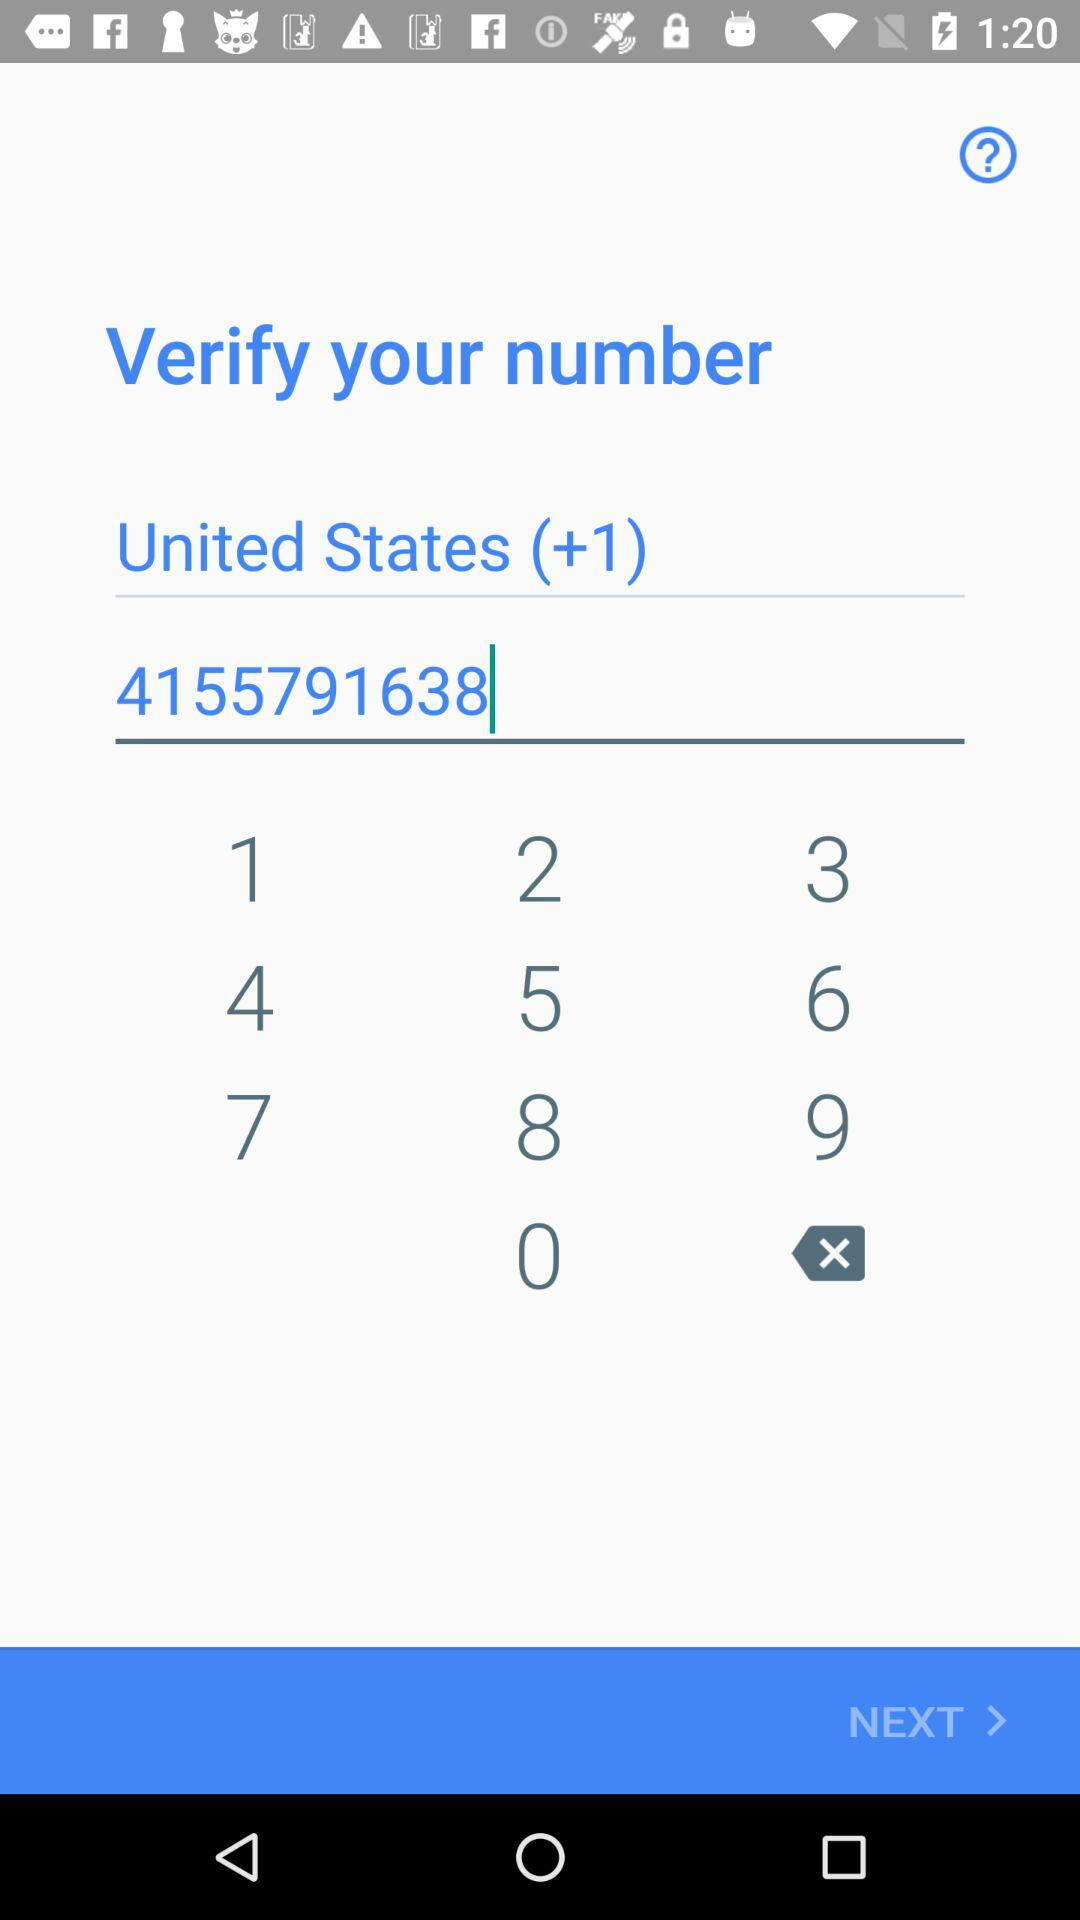What is the country name? The country name is the United States. 